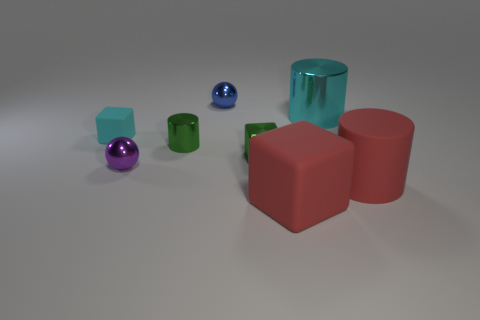Add 2 brown metal objects. How many objects exist? 10 Subtract all balls. How many objects are left? 6 Add 6 tiny metallic cylinders. How many tiny metallic cylinders exist? 7 Subtract 0 blue cubes. How many objects are left? 8 Subtract all yellow metal things. Subtract all tiny blue spheres. How many objects are left? 7 Add 7 red matte things. How many red matte things are left? 9 